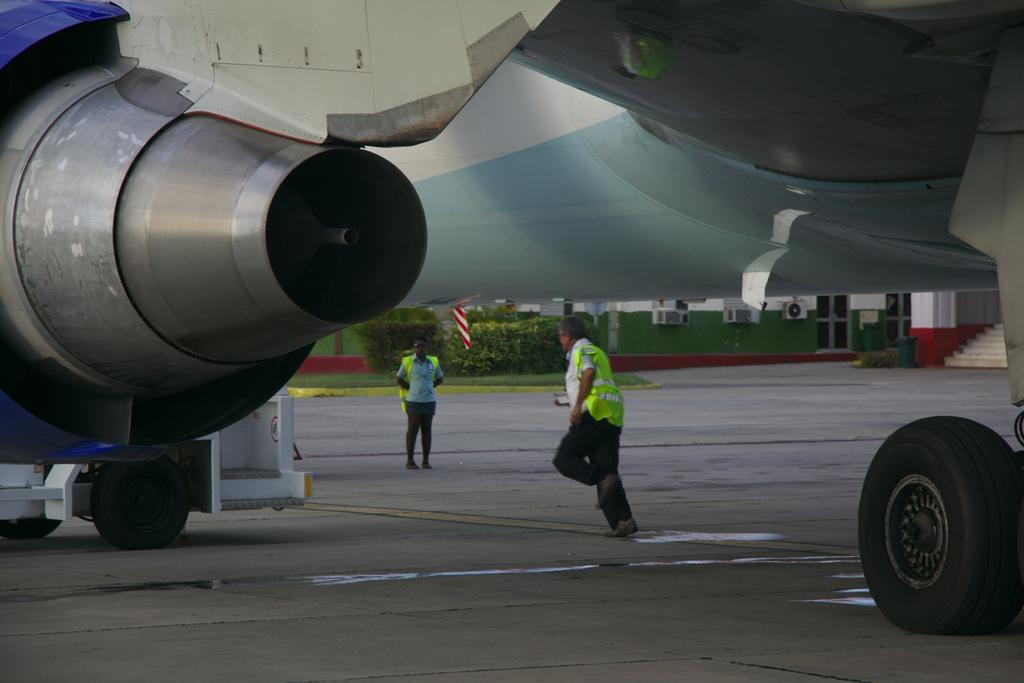In one or two sentences, can you explain what this image depicts? There is an aircraft on the road. Under this aircraft, there are persons on the road. In the background, there are plants and grass on the ground and there is a building. 